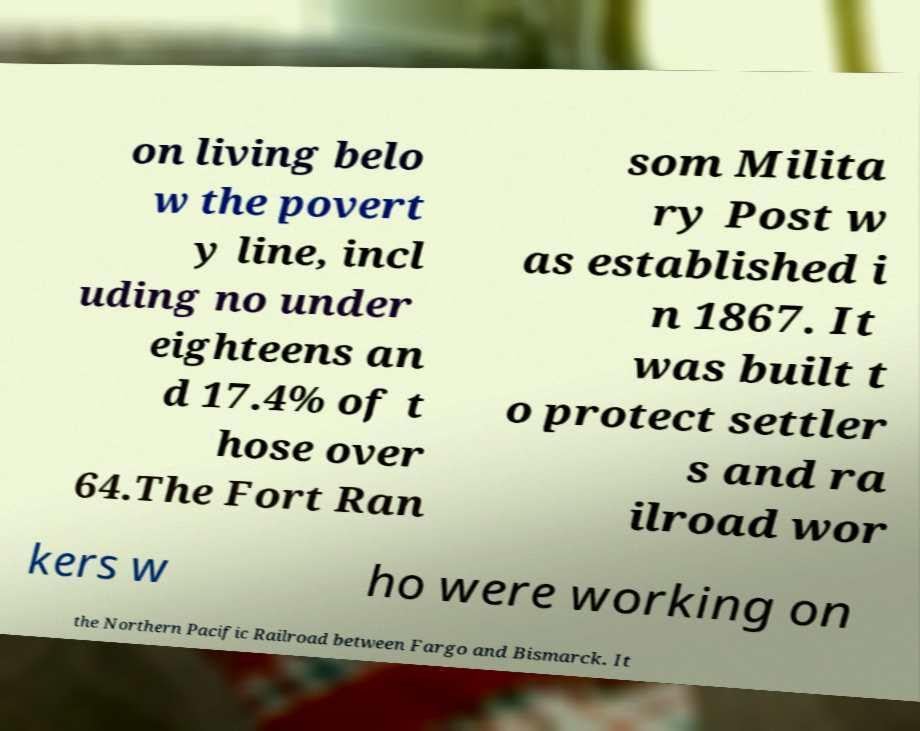Could you extract and type out the text from this image? on living belo w the povert y line, incl uding no under eighteens an d 17.4% of t hose over 64.The Fort Ran som Milita ry Post w as established i n 1867. It was built t o protect settler s and ra ilroad wor kers w ho were working on the Northern Pacific Railroad between Fargo and Bismarck. It 